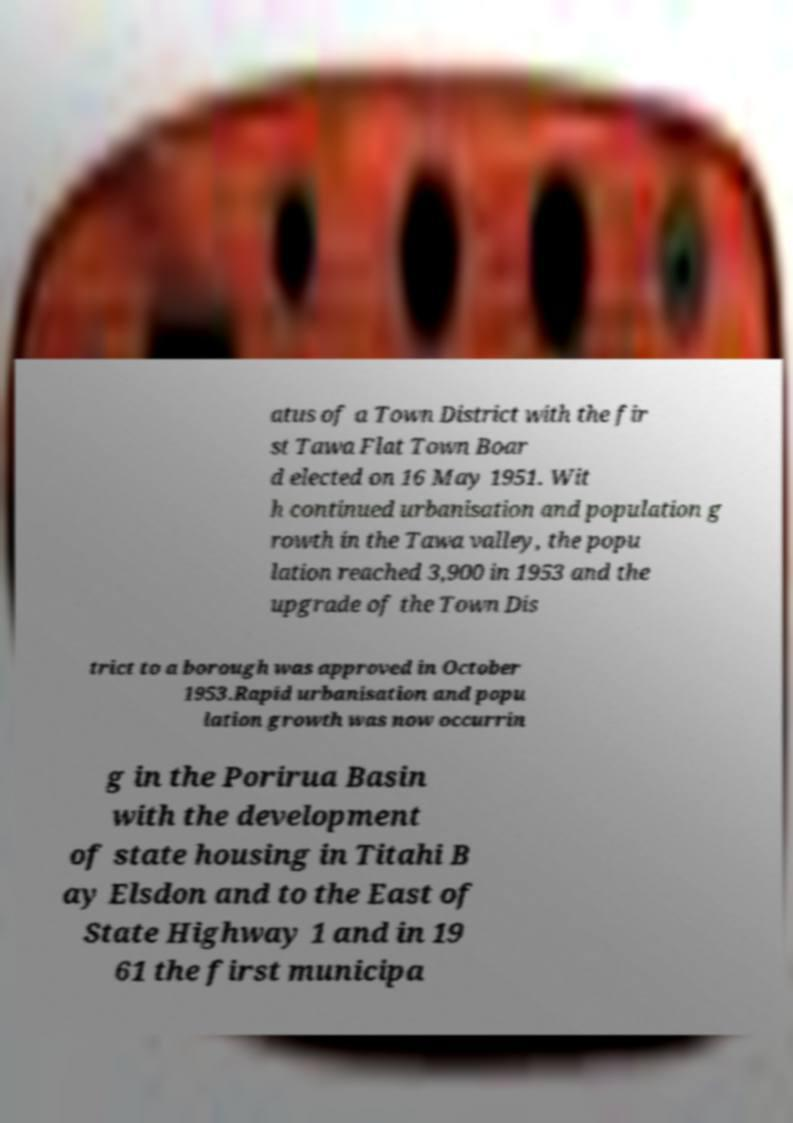There's text embedded in this image that I need extracted. Can you transcribe it verbatim? atus of a Town District with the fir st Tawa Flat Town Boar d elected on 16 May 1951. Wit h continued urbanisation and population g rowth in the Tawa valley, the popu lation reached 3,900 in 1953 and the upgrade of the Town Dis trict to a borough was approved in October 1953.Rapid urbanisation and popu lation growth was now occurrin g in the Porirua Basin with the development of state housing in Titahi B ay Elsdon and to the East of State Highway 1 and in 19 61 the first municipa 